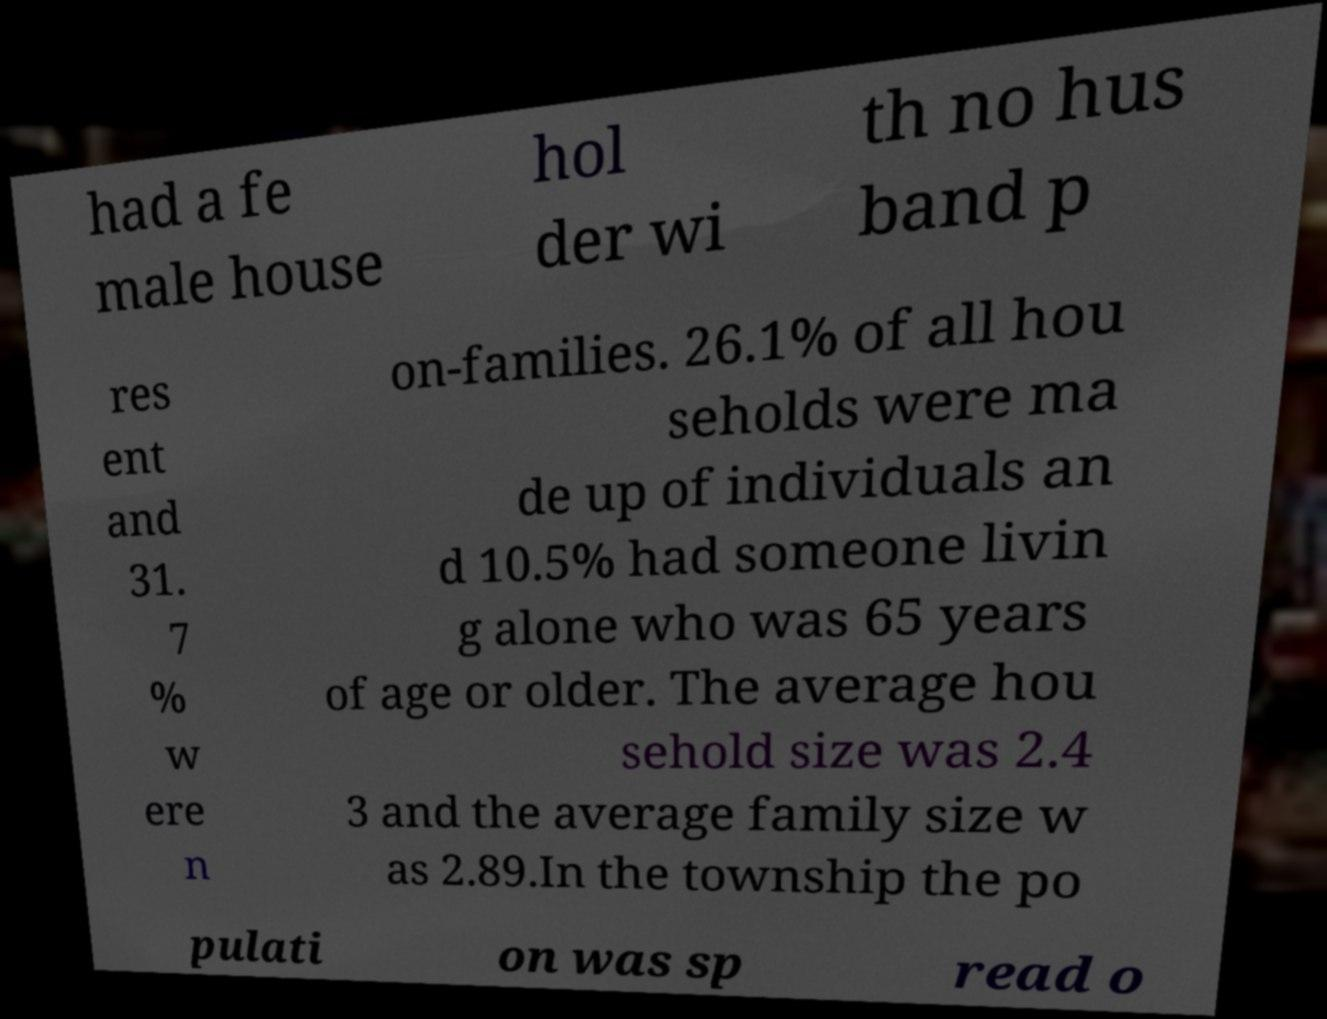Could you extract and type out the text from this image? had a fe male house hol der wi th no hus band p res ent and 31. 7 % w ere n on-families. 26.1% of all hou seholds were ma de up of individuals an d 10.5% had someone livin g alone who was 65 years of age or older. The average hou sehold size was 2.4 3 and the average family size w as 2.89.In the township the po pulati on was sp read o 